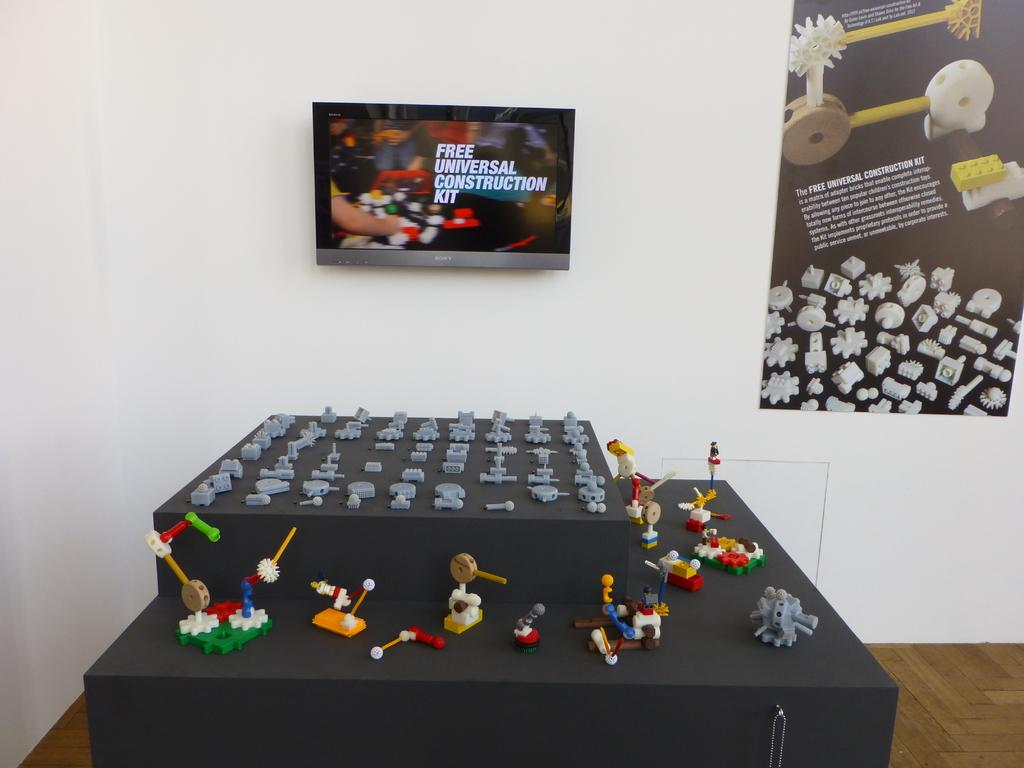<image>
Render a clear and concise summary of the photo. A gray table has figurines on it and a TV above it says Free Universal Construction Kit. 